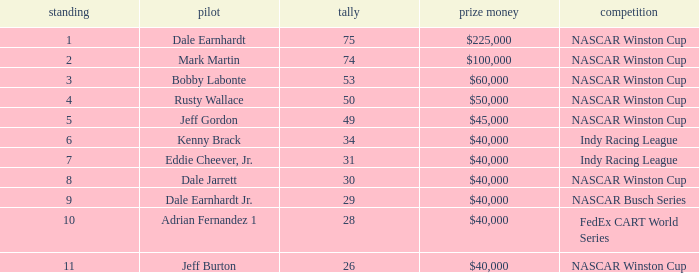What position did the driver earn 31 points? 7.0. 